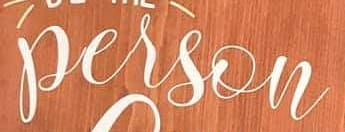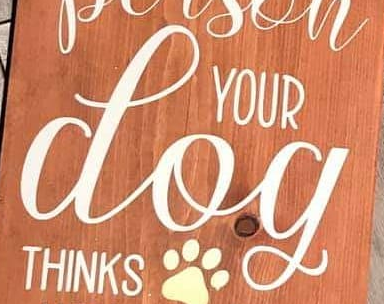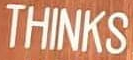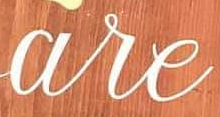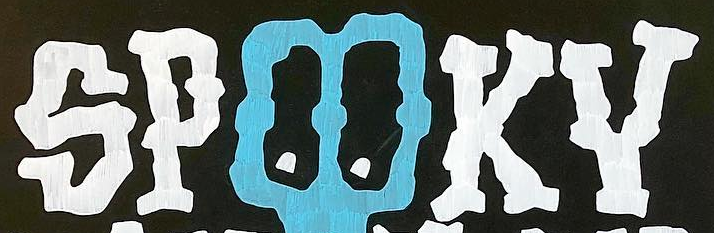What text is displayed in these images sequentially, separated by a semicolon? person; dog; THINKS; are; SPOOKY 